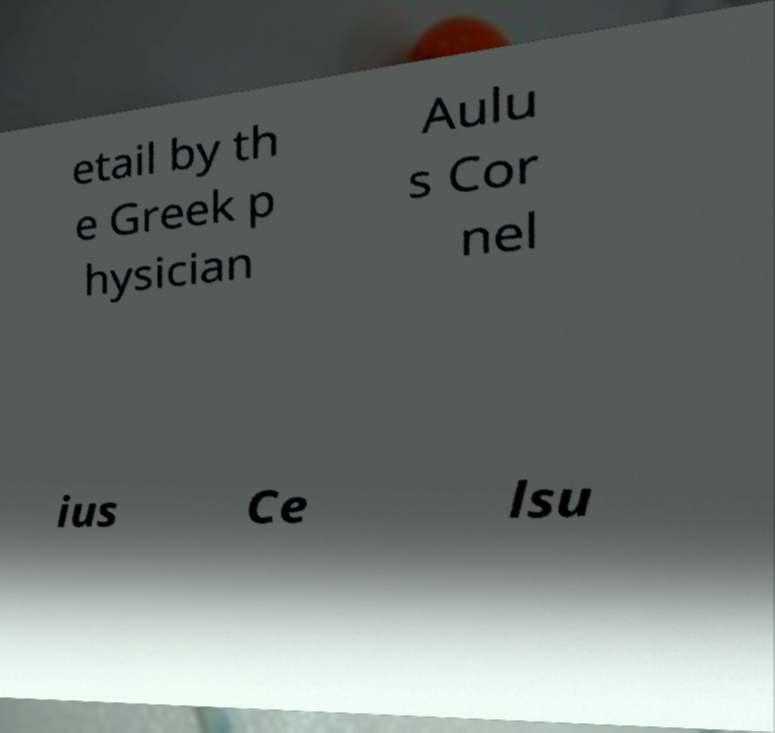Can you accurately transcribe the text from the provided image for me? etail by th e Greek p hysician Aulu s Cor nel ius Ce lsu 